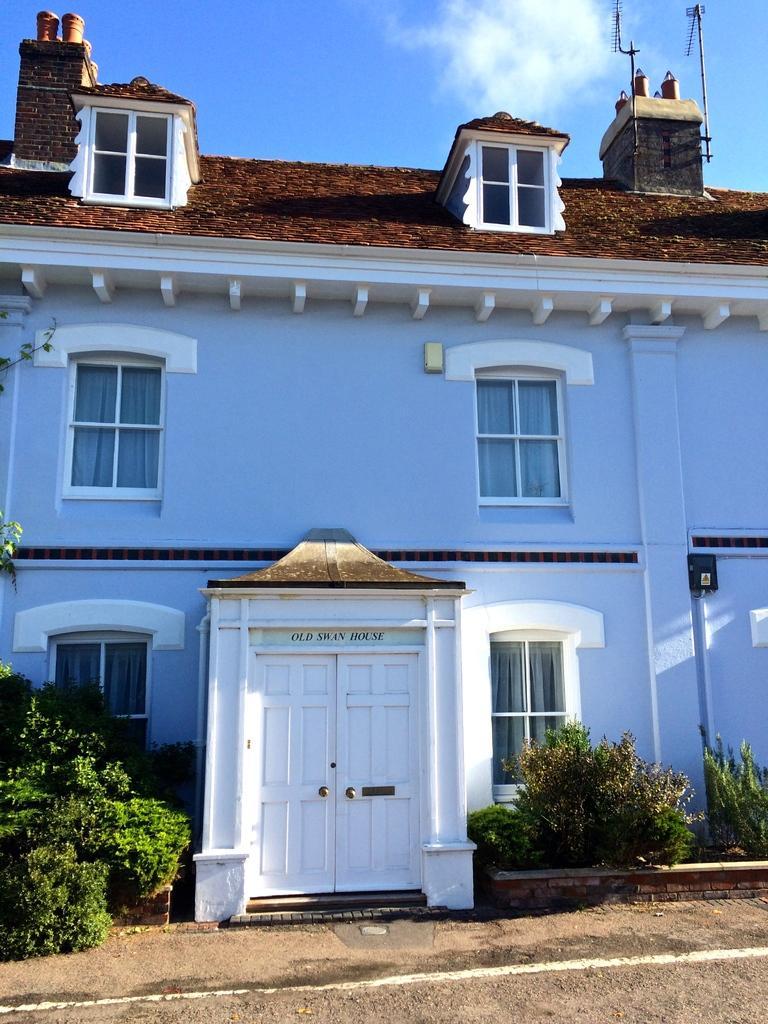Can you describe this image briefly? In this image there is a big building with white door and glass windows in front of that there are so many plants. 